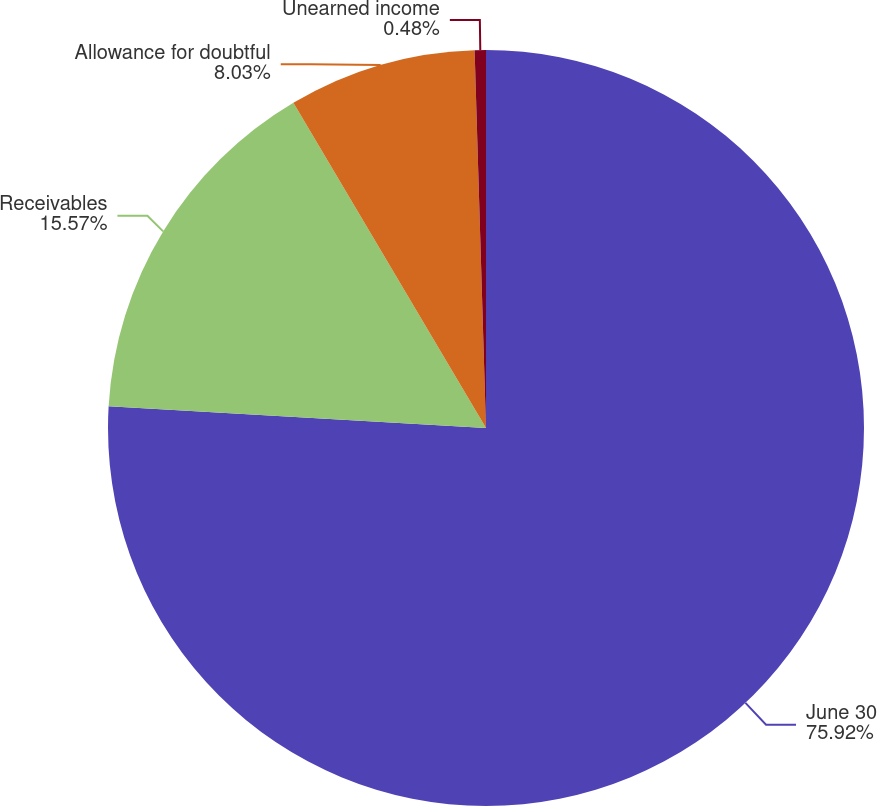Convert chart to OTSL. <chart><loc_0><loc_0><loc_500><loc_500><pie_chart><fcel>June 30<fcel>Receivables<fcel>Allowance for doubtful<fcel>Unearned income<nl><fcel>75.92%<fcel>15.57%<fcel>8.03%<fcel>0.48%<nl></chart> 